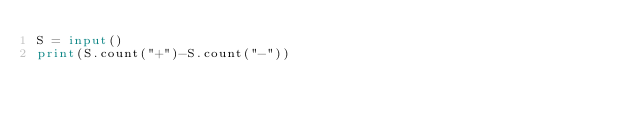Convert code to text. <code><loc_0><loc_0><loc_500><loc_500><_Python_>S = input()
print(S.count("+")-S.count("-"))</code> 